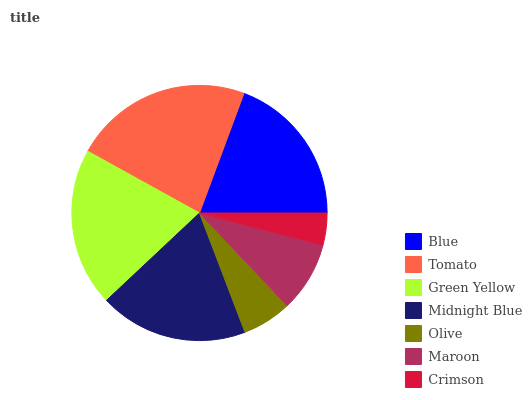Is Crimson the minimum?
Answer yes or no. Yes. Is Tomato the maximum?
Answer yes or no. Yes. Is Green Yellow the minimum?
Answer yes or no. No. Is Green Yellow the maximum?
Answer yes or no. No. Is Tomato greater than Green Yellow?
Answer yes or no. Yes. Is Green Yellow less than Tomato?
Answer yes or no. Yes. Is Green Yellow greater than Tomato?
Answer yes or no. No. Is Tomato less than Green Yellow?
Answer yes or no. No. Is Midnight Blue the high median?
Answer yes or no. Yes. Is Midnight Blue the low median?
Answer yes or no. Yes. Is Crimson the high median?
Answer yes or no. No. Is Maroon the low median?
Answer yes or no. No. 